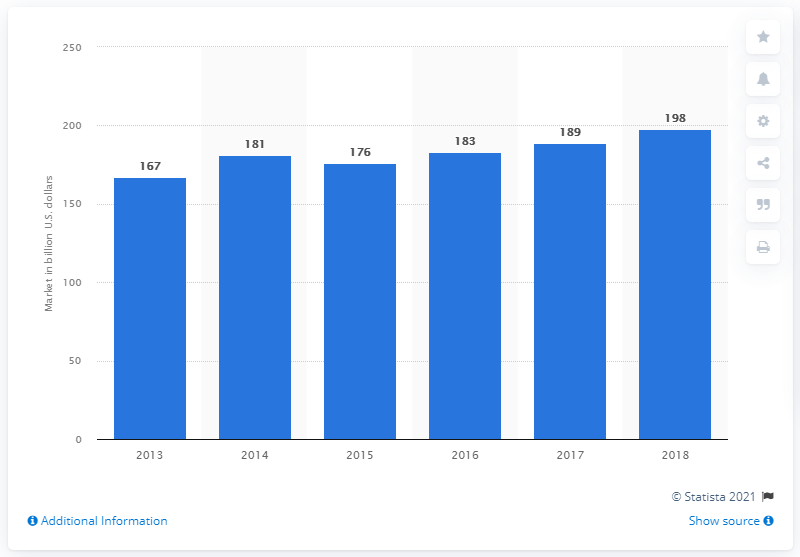Highlight a few significant elements in this photo. In 2018, the amount of dollars spent on business process management was 198.. 